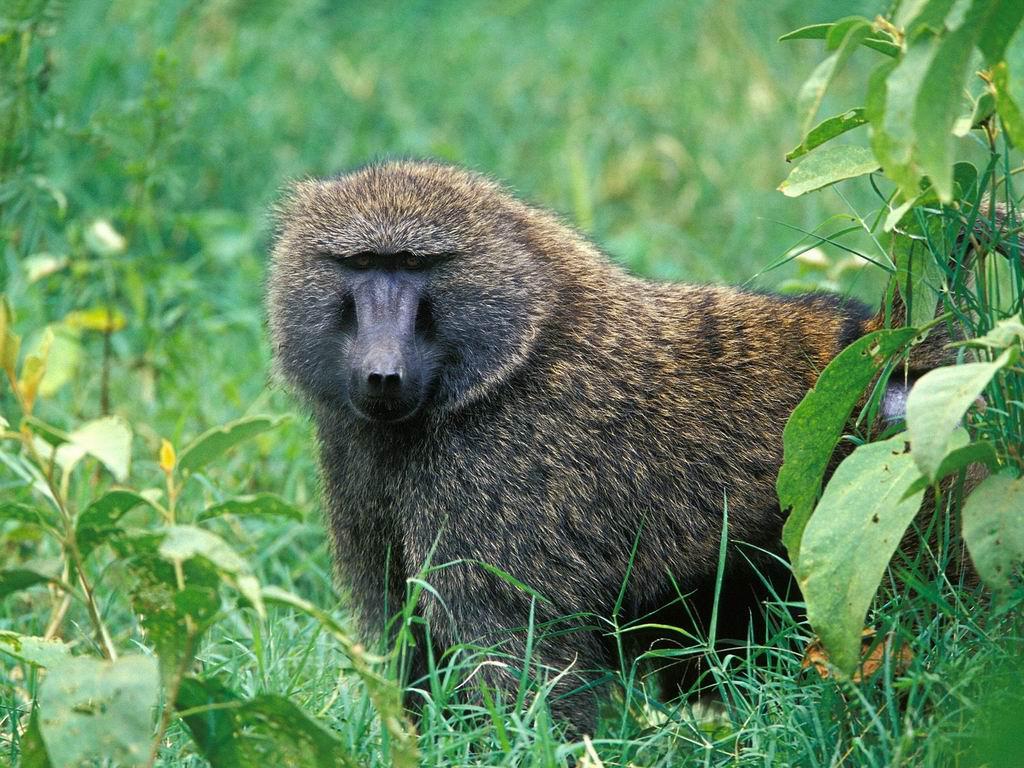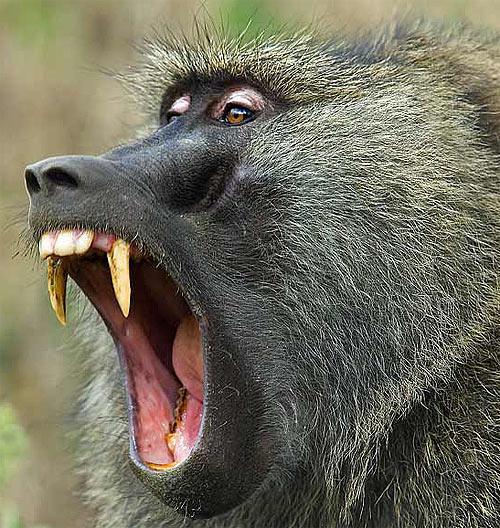The first image is the image on the left, the second image is the image on the right. Analyze the images presented: Is the assertion "In one of the images, the animal's mouth is open as it bears its teeth" valid? Answer yes or no. Yes. 